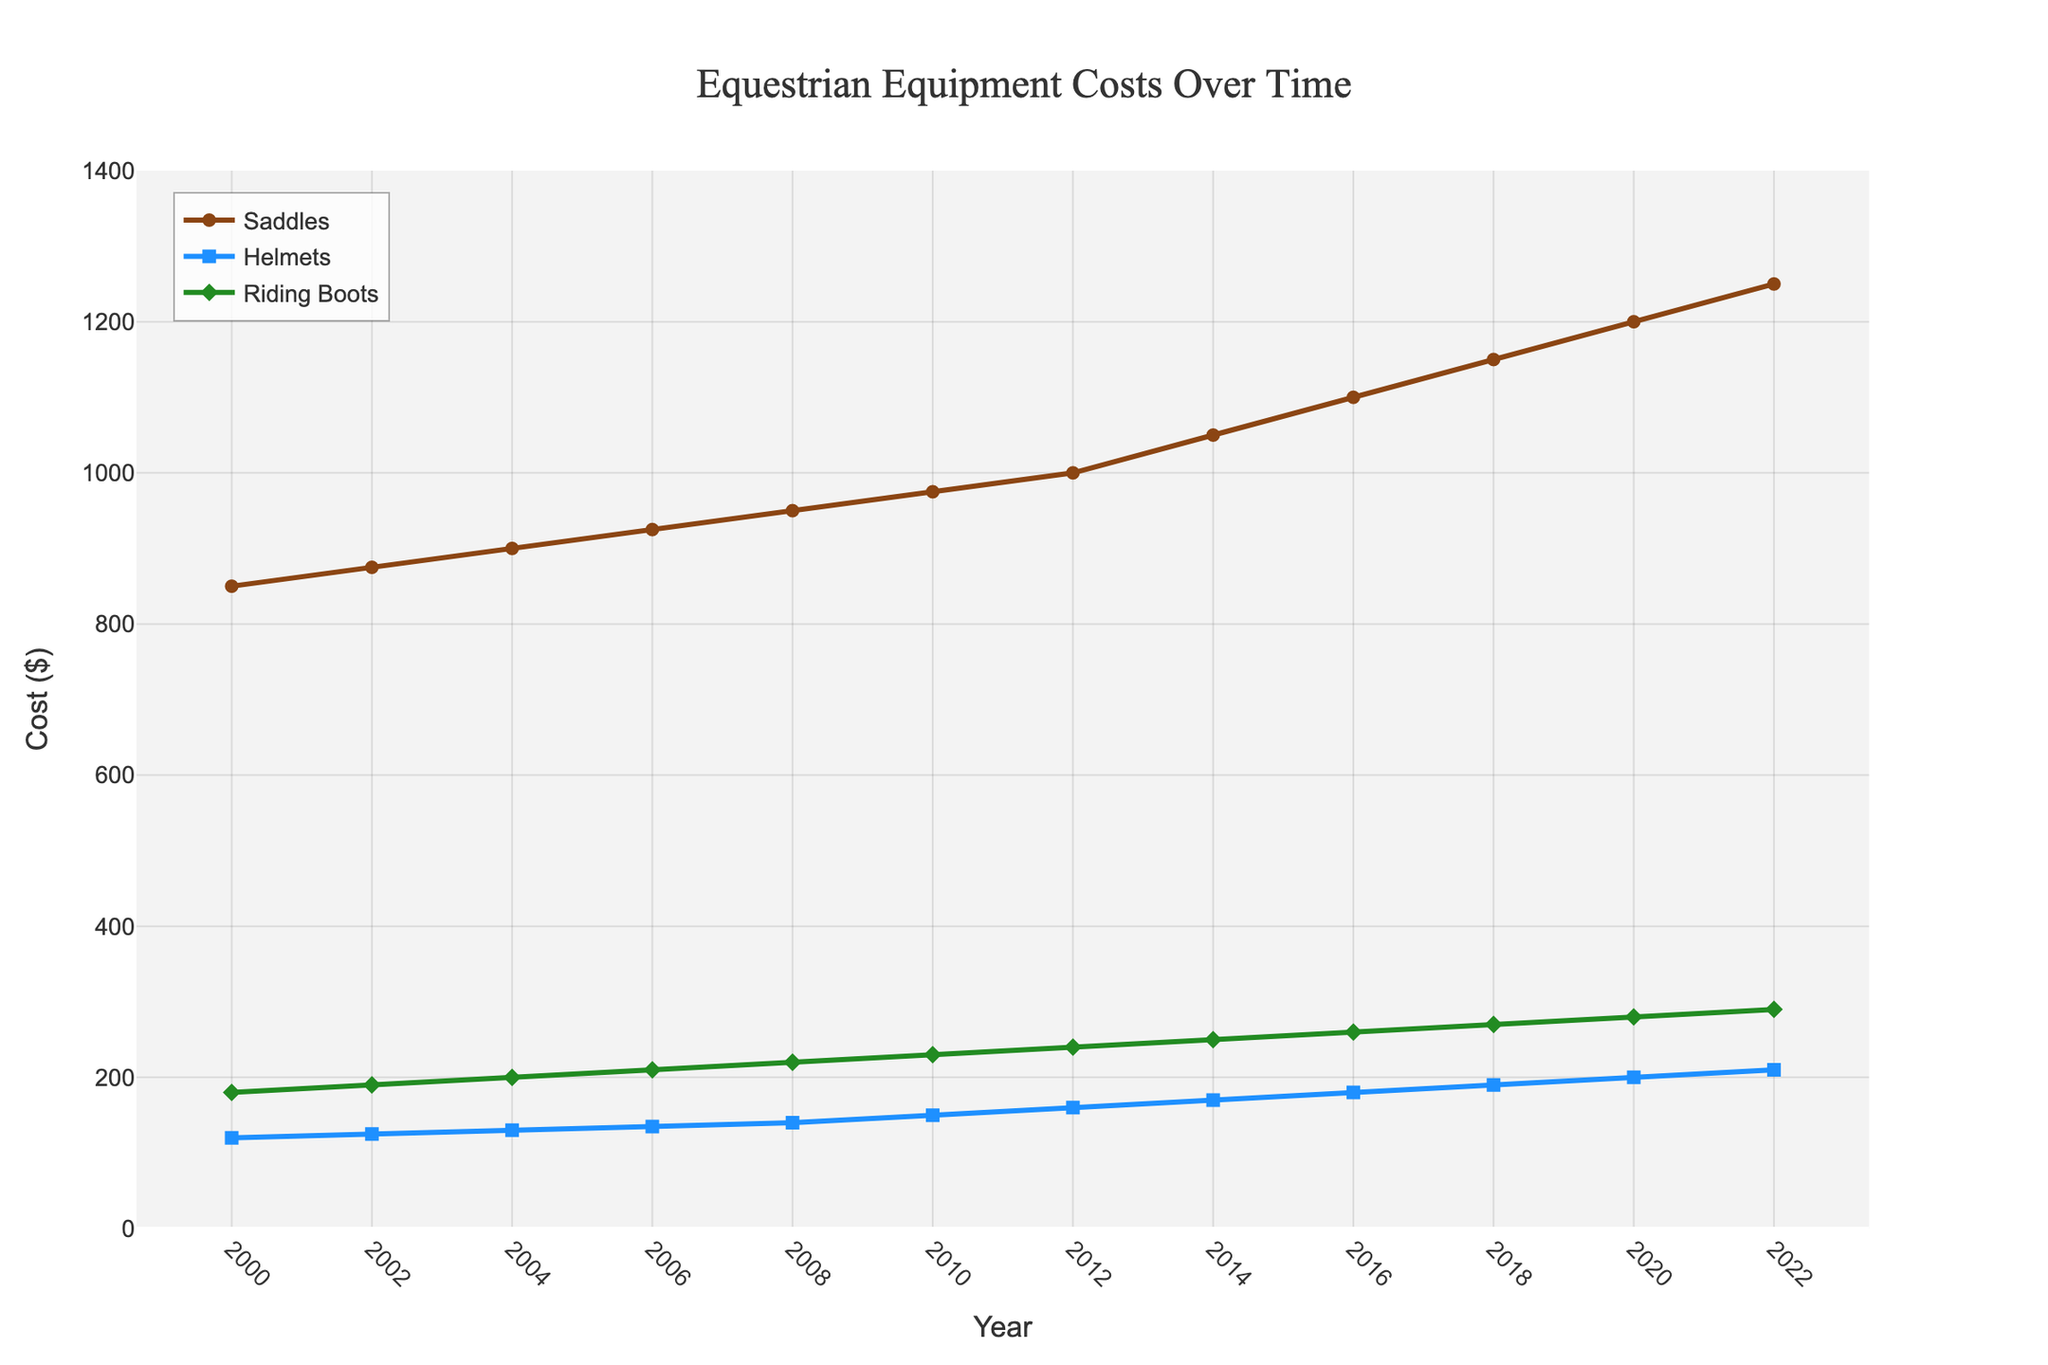What's the trend in the cost of saddles from 2000 to 2022? From the figure, the cost of saddles steadily increases over time from 850 in 2000 to 1250 in 2022. The slope of the line indicates a consistent rise.
Answer: The cost of saddles increases over time In which year did the cost of helmets reach 150 dollars? From the figure, the line representing helmets reaches 150 dollars in the year 2010. Identify where the helmet line intersects with the 150-dollar mark on the Y-axis.
Answer: 2010 By how much did the cost of riding boots increase from 2000 to 2022? In 2000, the cost of riding boots was 180, and in 2022, it was 290. Calculate the difference: 290 - 180 = 110.
Answer: 110 How does the increase in cost for saddles compare to that for helmets between 2000 and 2022? Saddles increased from 850 to 1250 (an increase of 400), while helmets increased from 120 to 210 (an increase of 90). The increase for saddles is 400, which is greater than the increase for helmets (90).
Answer: Saddles increased by 400, helmets by 90 Which category consistently had the highest costs over the years? From the figure, the line representing saddles is always higher on the Y-axis compared to helmets and riding boots for every year.
Answer: Saddles Did the cost of any equipment decrease at any point in time? Examine the lines for any dips or downward trends. All lines for saddles, helmets, and riding boots show a consistent upward trend with no decreases.
Answer: No What is the average cost of riding boots from 2000 to 2022? Adding all values: 180 + 190 + 200 + 210 + 220 + 230 + 240 + 250 + 260 + 270 + 280 + 290 = 2820. Divide by 12 (number of years): 2820 / 12 = 235.
Answer: 235 Which year saw the highest rate of increase in the cost of helmets? Identify the years with the steepest slopes in the helmet cost line. The slope from 2010-2012 (150 to 160) and 2012-2014 (160 to 170) shows a steeper rise compared to other years.
Answer: 2010-2012 and 2012-2014 By how much did the cost of saddles increase during the period from 2004 to 2006? In 2004, the cost of saddles was 900, and in 2006 it was 925. Calculate the difference: 925 - 900 = 25.
Answer: 25 Which category saw the most significant change in cost between 2000 and 2006? Compare the differences: Saddles increased from 850 to 925 (75), helmets from 120 to 135 (15), and riding boots from 180 to 210 (30). The most significant change is in saddles with an increase of 75.
Answer: Saddles 